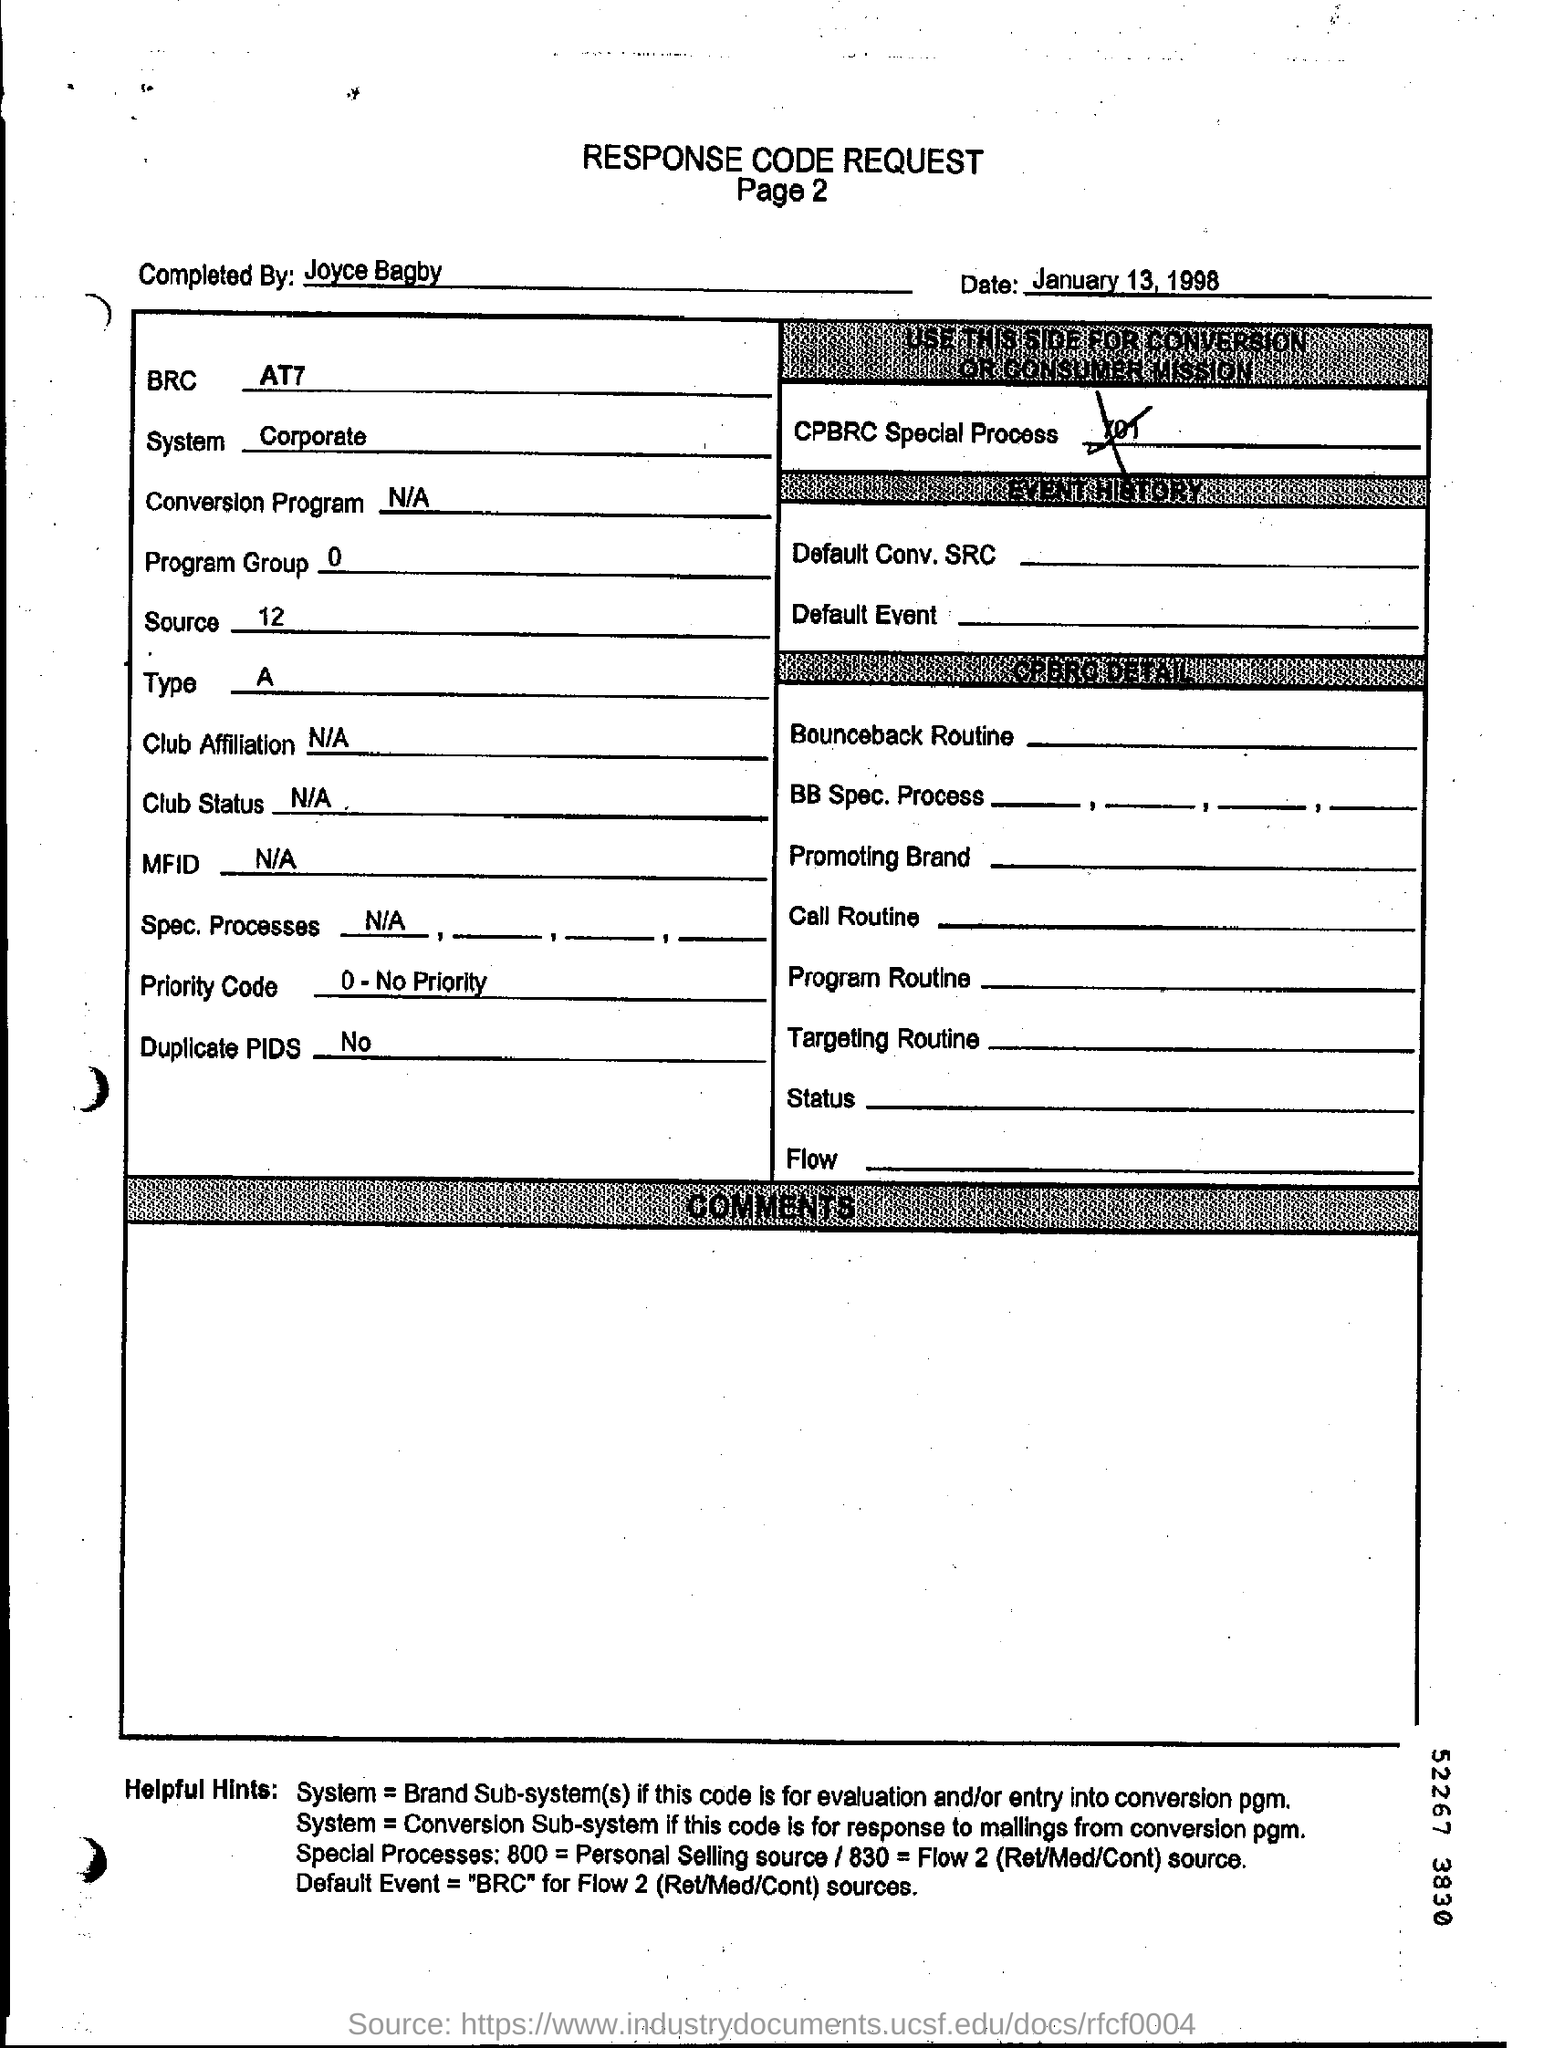Mention the page number below response code request ?
Provide a short and direct response. Page 2. Who completed this response code request ?
Your response must be concise. Joyce bagby. When is the response code request dated ?
Make the answer very short. January 13, 1998. 